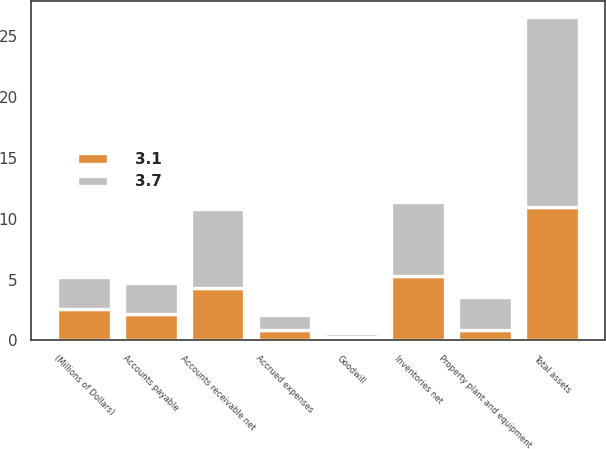Convert chart. <chart><loc_0><loc_0><loc_500><loc_500><stacked_bar_chart><ecel><fcel>(Millions of Dollars)<fcel>Accounts receivable net<fcel>Inventories net<fcel>Property plant and equipment<fcel>Goodwill<fcel>Total assets<fcel>Accounts payable<fcel>Accrued expenses<nl><fcel>3.1<fcel>2.6<fcel>4.3<fcel>5.3<fcel>0.9<fcel>0.3<fcel>11<fcel>2.2<fcel>0.9<nl><fcel>3.7<fcel>2.6<fcel>6.5<fcel>6.1<fcel>2.7<fcel>0.3<fcel>15.6<fcel>2.5<fcel>1.2<nl></chart> 